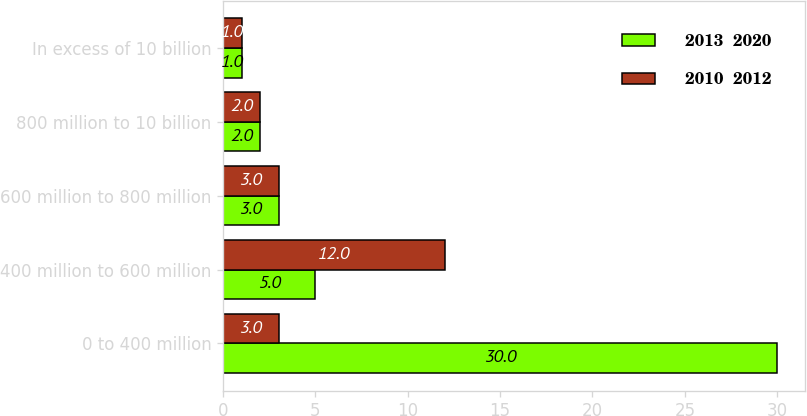Convert chart to OTSL. <chart><loc_0><loc_0><loc_500><loc_500><stacked_bar_chart><ecel><fcel>0 to 400 million<fcel>400 million to 600 million<fcel>600 million to 800 million<fcel>800 million to 10 billion<fcel>In excess of 10 billion<nl><fcel>2013  2020<fcel>30<fcel>5<fcel>3<fcel>2<fcel>1<nl><fcel>2010  2012<fcel>3<fcel>12<fcel>3<fcel>2<fcel>1<nl></chart> 